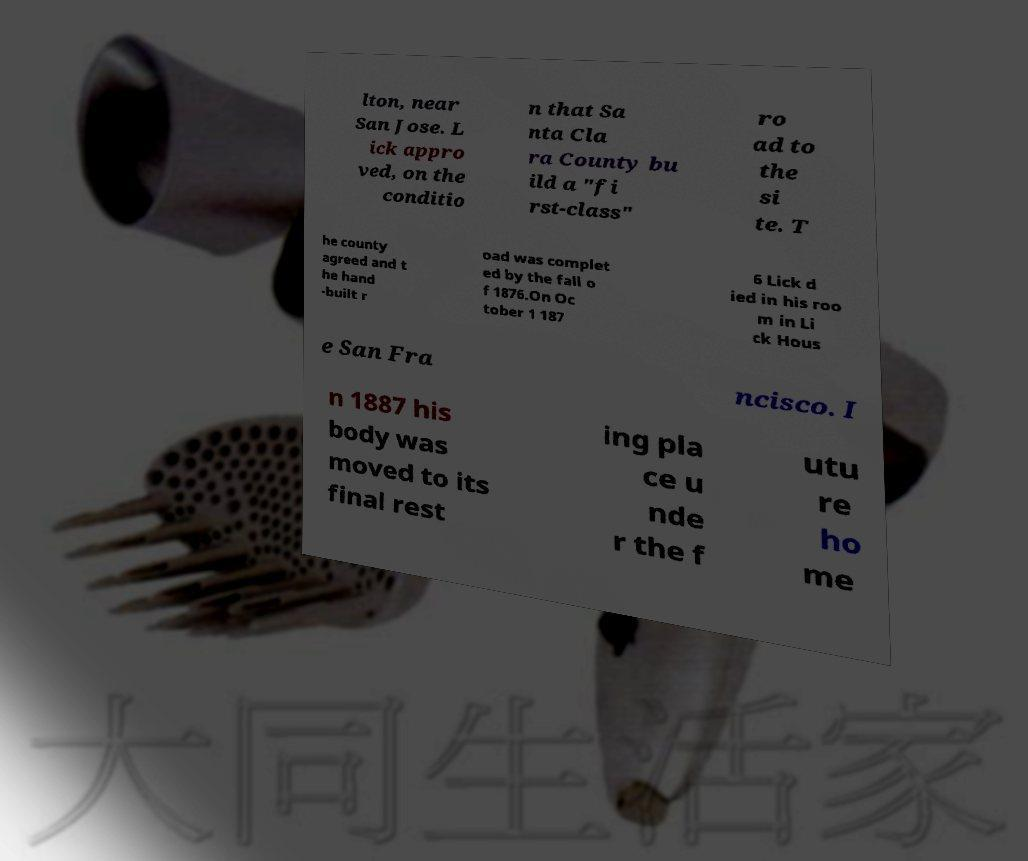Can you read and provide the text displayed in the image?This photo seems to have some interesting text. Can you extract and type it out for me? lton, near San Jose. L ick appro ved, on the conditio n that Sa nta Cla ra County bu ild a "fi rst-class" ro ad to the si te. T he county agreed and t he hand -built r oad was complet ed by the fall o f 1876.On Oc tober 1 187 6 Lick d ied in his roo m in Li ck Hous e San Fra ncisco. I n 1887 his body was moved to its final rest ing pla ce u nde r the f utu re ho me 